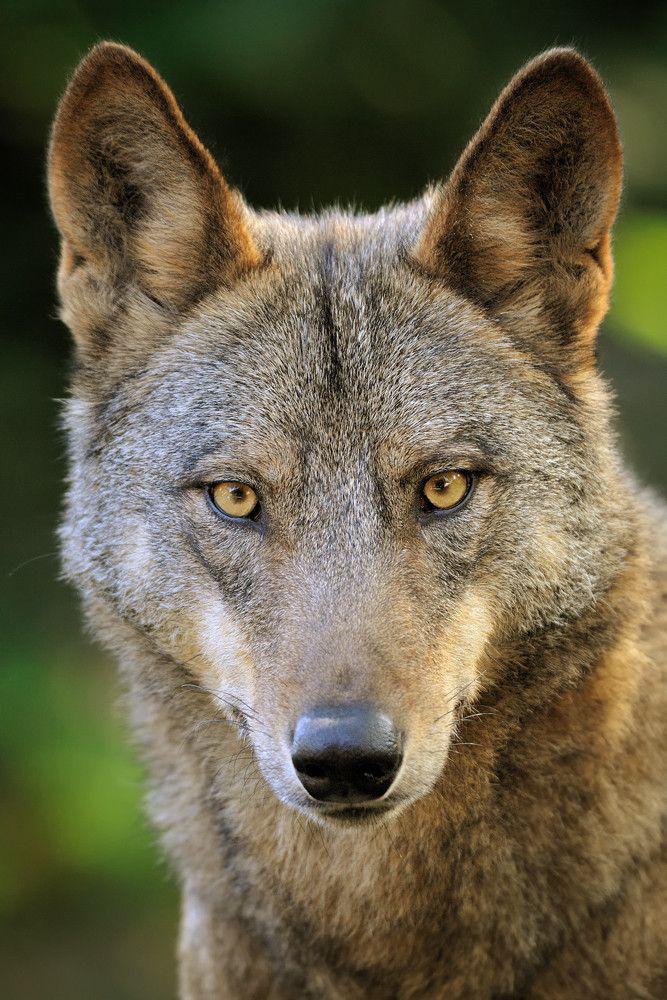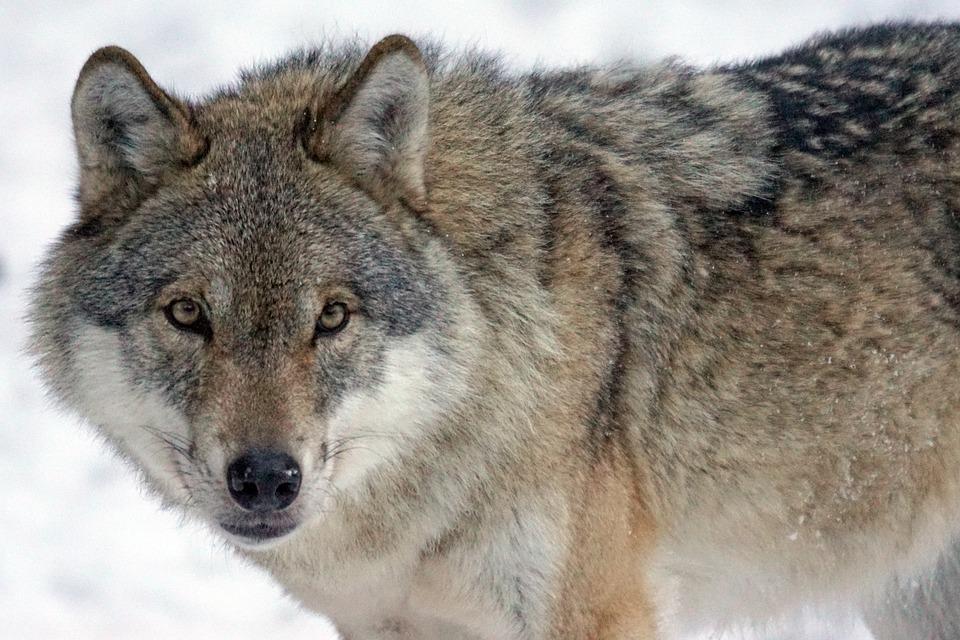The first image is the image on the left, the second image is the image on the right. For the images displayed, is the sentence "There is at least one wolf with over 80% white and yellow fur covering their face." factually correct? Answer yes or no. No. 